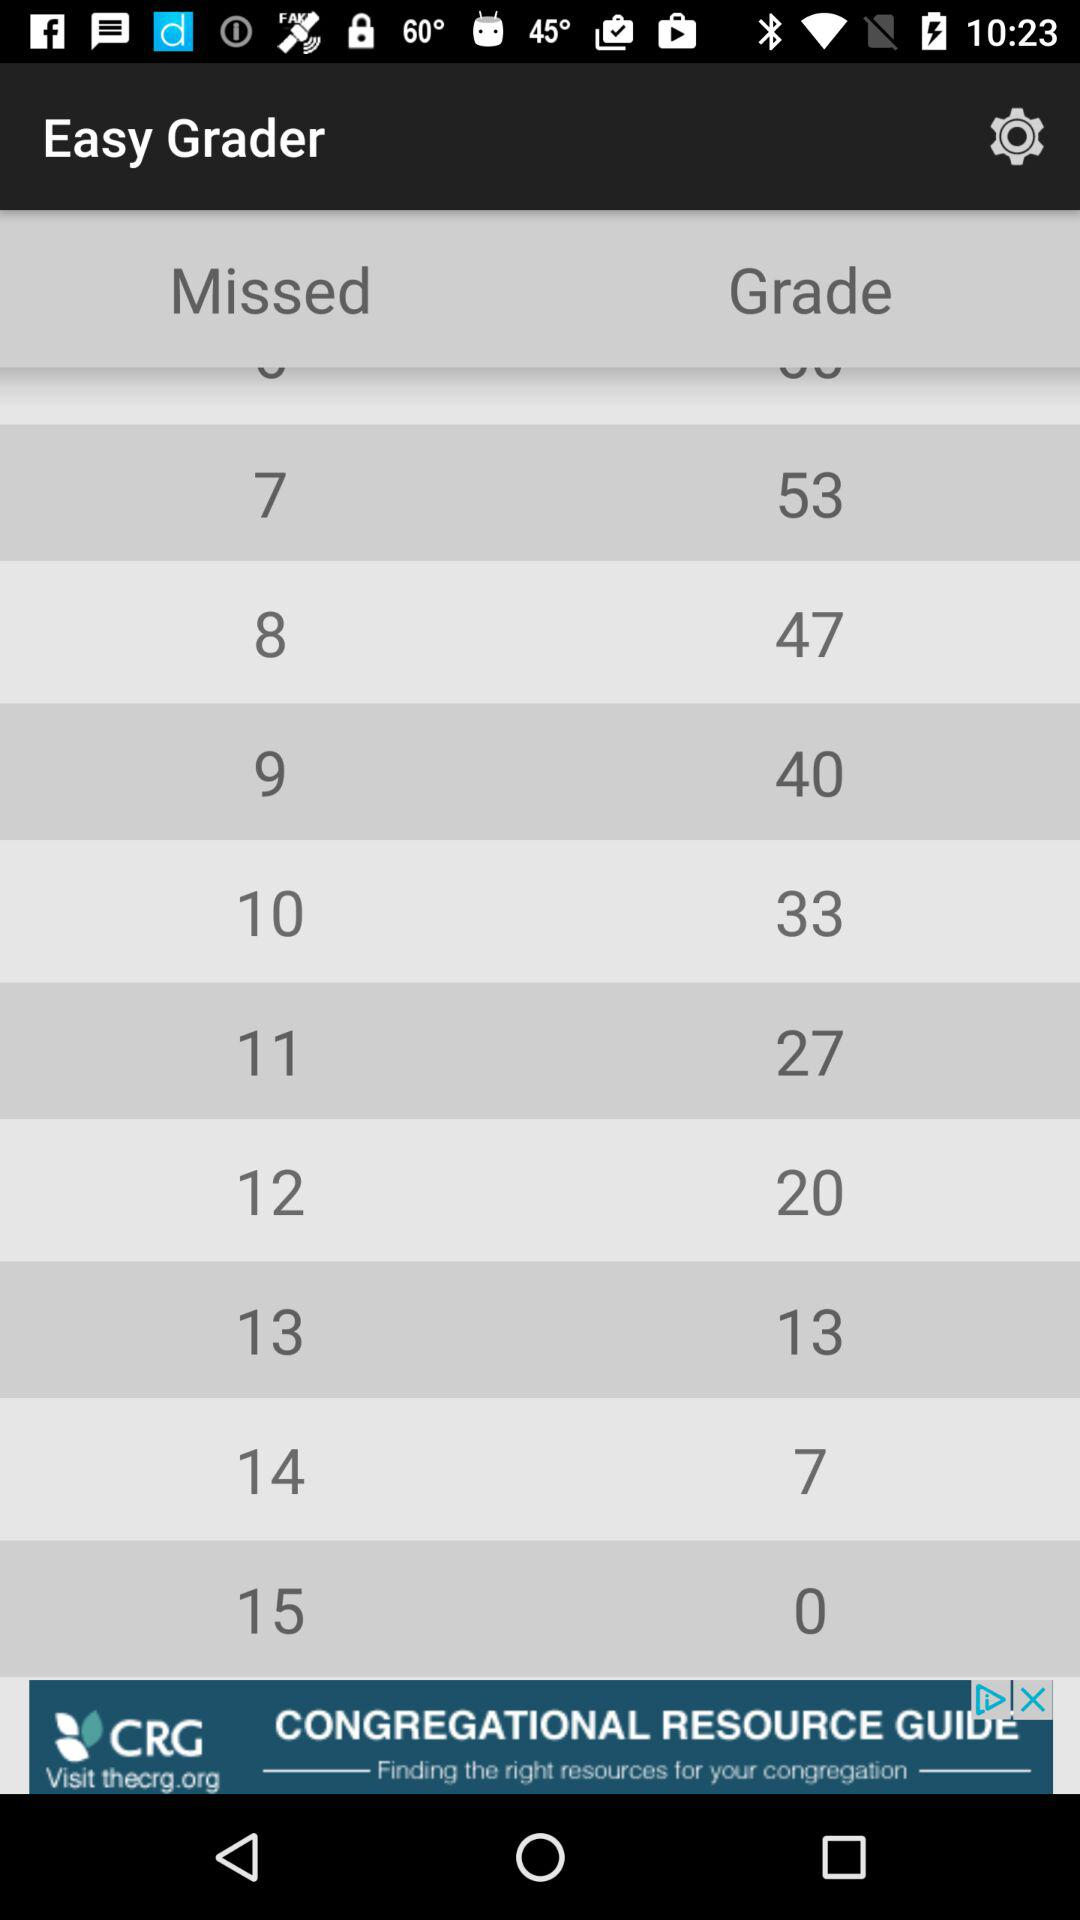What is the version of this application?
When the provided information is insufficient, respond with <no answer>. <no answer> 